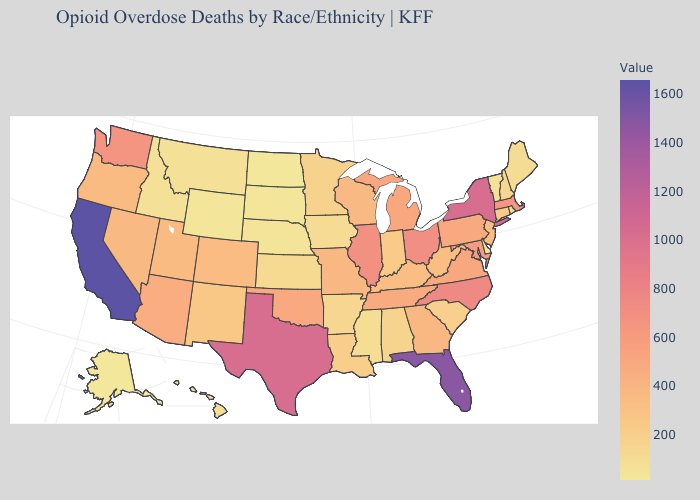Which states have the lowest value in the Northeast?
Be succinct. Vermont. Does Maryland have the highest value in the South?
Write a very short answer. No. Does the map have missing data?
Write a very short answer. No. Does New York have the highest value in the Northeast?
Short answer required. Yes. Does Louisiana have a lower value than North Dakota?
Concise answer only. No. 